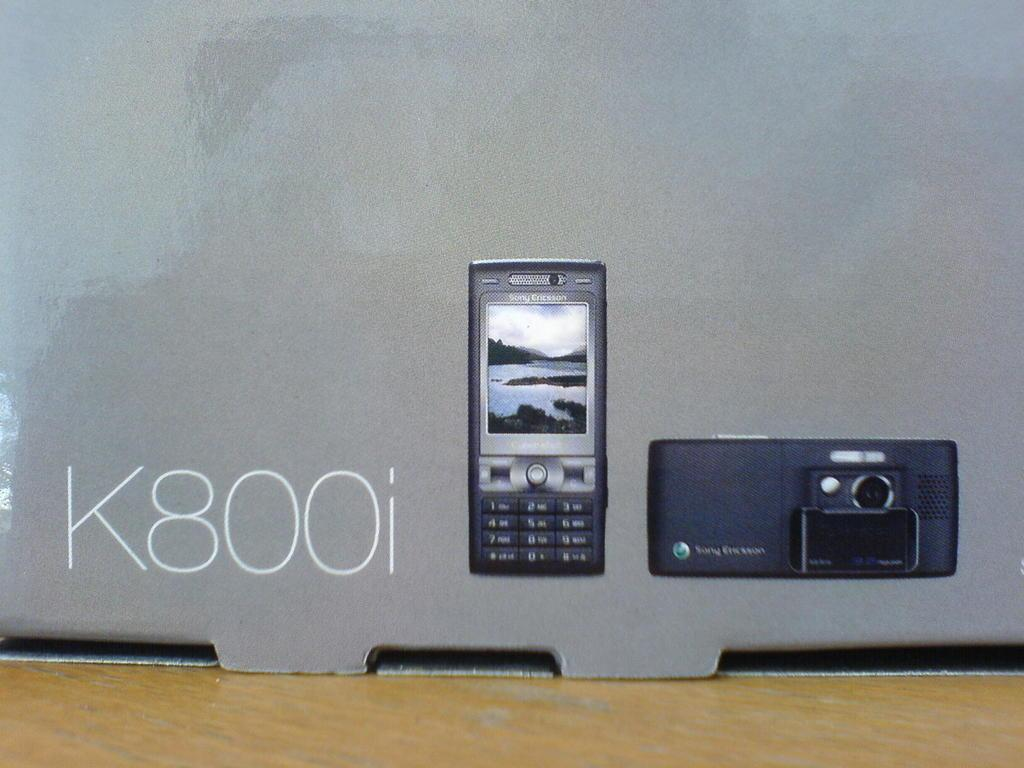Provide a one-sentence caption for the provided image. A box says K800i next to a photo of a phone and a photo of a camera. 